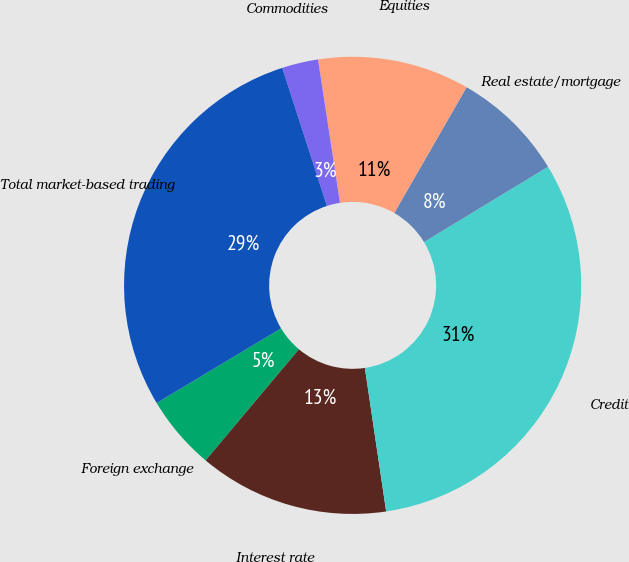Convert chart. <chart><loc_0><loc_0><loc_500><loc_500><pie_chart><fcel>Foreign exchange<fcel>Interest rate<fcel>Credit<fcel>Real estate/mortgage<fcel>Equities<fcel>Commodities<fcel>Total market-based trading<nl><fcel>5.28%<fcel>13.46%<fcel>31.34%<fcel>8.01%<fcel>10.73%<fcel>2.56%<fcel>28.62%<nl></chart> 